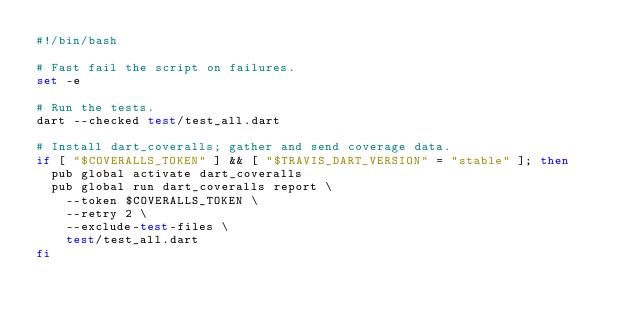Convert code to text. <code><loc_0><loc_0><loc_500><loc_500><_Bash_>#!/bin/bash

# Fast fail the script on failures.   
set -e

# Run the tests.
dart --checked test/test_all.dart

# Install dart_coveralls; gather and send coverage data.
if [ "$COVERALLS_TOKEN" ] && [ "$TRAVIS_DART_VERSION" = "stable" ]; then
  pub global activate dart_coveralls
  pub global run dart_coveralls report \
    --token $COVERALLS_TOKEN \
    --retry 2 \
    --exclude-test-files \
    test/test_all.dart
fi</code> 